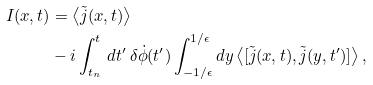Convert formula to latex. <formula><loc_0><loc_0><loc_500><loc_500>I ( x , t ) & = \left \langle \tilde { j } ( x , t ) \right \rangle \\ & - i \int _ { t _ { n } } ^ { t } \, d t ^ { \prime } \, \delta \dot { \phi } ( t ^ { \prime } ) \int _ { - 1 / \epsilon } ^ { 1 / \epsilon } d y \left \langle [ \tilde { j } ( x , t ) , \tilde { j } ( y , t ^ { \prime } ) ] \right \rangle ,</formula> 